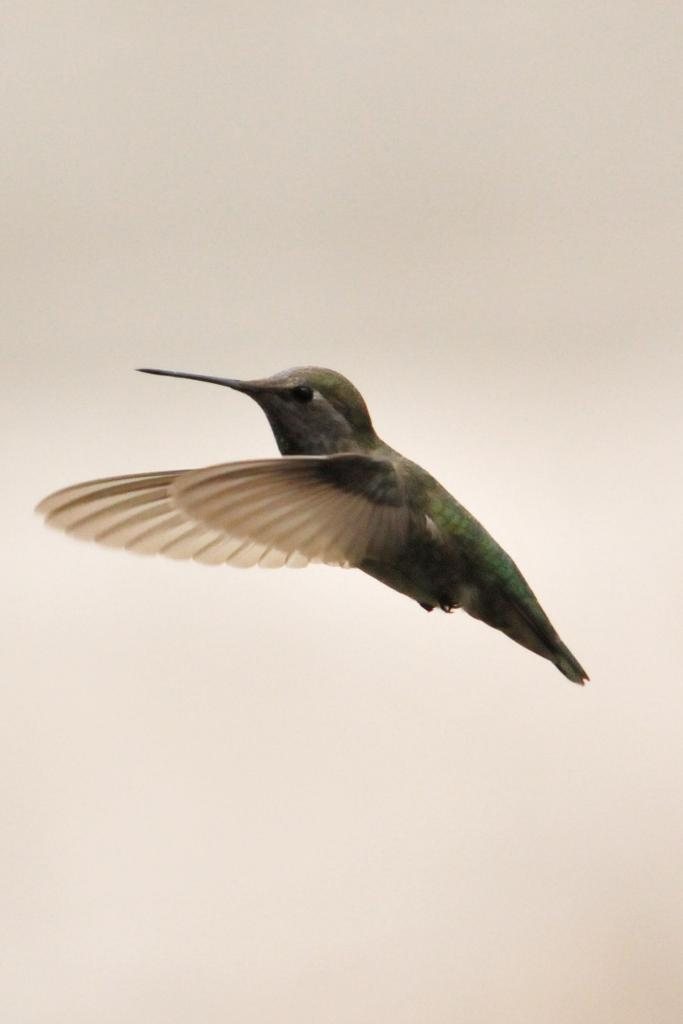What type of animal can be seen in the image? There is a bird in the image. What is the bird doing in the image? The bird is flying in the sky. What type of glove is the governor wearing in the image? There is no glove or governor present in the image; it only features a bird flying in the sky. 